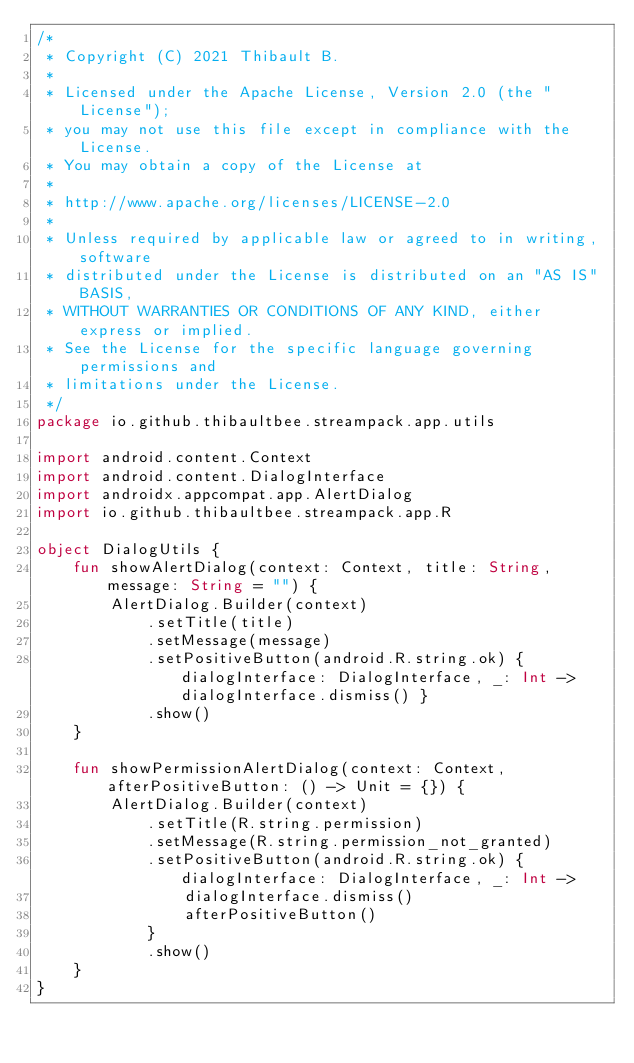<code> <loc_0><loc_0><loc_500><loc_500><_Kotlin_>/*
 * Copyright (C) 2021 Thibault B.
 *
 * Licensed under the Apache License, Version 2.0 (the "License");
 * you may not use this file except in compliance with the License.
 * You may obtain a copy of the License at
 *
 * http://www.apache.org/licenses/LICENSE-2.0
 *
 * Unless required by applicable law or agreed to in writing, software
 * distributed under the License is distributed on an "AS IS" BASIS,
 * WITHOUT WARRANTIES OR CONDITIONS OF ANY KIND, either express or implied.
 * See the License for the specific language governing permissions and
 * limitations under the License.
 */
package io.github.thibaultbee.streampack.app.utils

import android.content.Context
import android.content.DialogInterface
import androidx.appcompat.app.AlertDialog
import io.github.thibaultbee.streampack.app.R

object DialogUtils {
    fun showAlertDialog(context: Context, title: String, message: String = "") {
        AlertDialog.Builder(context)
            .setTitle(title)
            .setMessage(message)
            .setPositiveButton(android.R.string.ok) { dialogInterface: DialogInterface, _: Int -> dialogInterface.dismiss() }
            .show()
    }

    fun showPermissionAlertDialog(context: Context, afterPositiveButton: () -> Unit = {}) {
        AlertDialog.Builder(context)
            .setTitle(R.string.permission)
            .setMessage(R.string.permission_not_granted)
            .setPositiveButton(android.R.string.ok) { dialogInterface: DialogInterface, _: Int ->
                dialogInterface.dismiss()
                afterPositiveButton()
            }
            .show()
    }
}</code> 